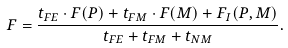<formula> <loc_0><loc_0><loc_500><loc_500>F = \frac { { t _ { F E } \cdot F ( P ) + t _ { F M } \cdot F ( M ) + F _ { I } ( P , M ) } } { { t _ { F E } + t _ { F M } + t _ { N M } } } .</formula> 